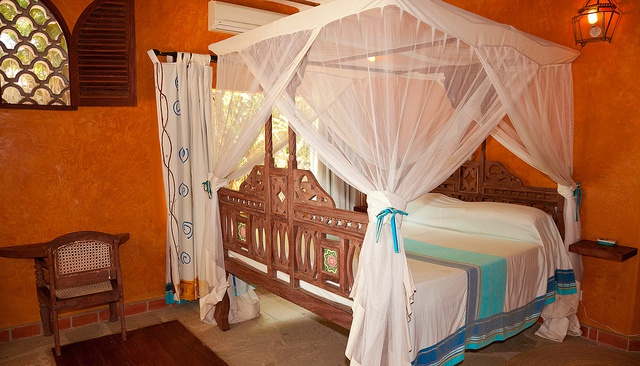Describe the objects in this image and their specific colors. I can see bed in maroon, tan, darkgray, and gray tones, chair in maroon, black, and brown tones, and remote in maroon, gray, and tan tones in this image. 